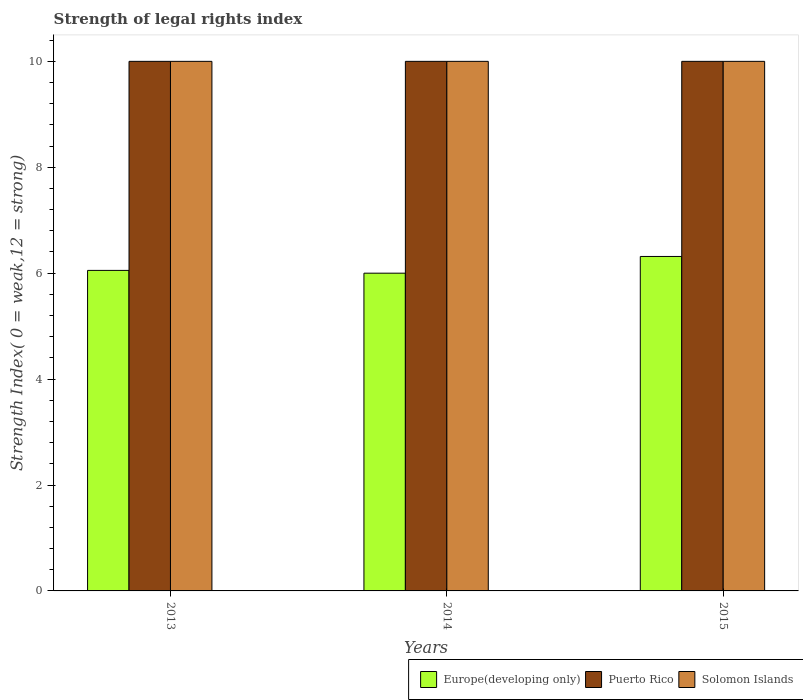How many different coloured bars are there?
Offer a very short reply. 3. Are the number of bars per tick equal to the number of legend labels?
Provide a short and direct response. Yes. Are the number of bars on each tick of the X-axis equal?
Ensure brevity in your answer.  Yes. How many bars are there on the 3rd tick from the right?
Your response must be concise. 3. What is the label of the 2nd group of bars from the left?
Your response must be concise. 2014. What is the strength index in Europe(developing only) in 2015?
Ensure brevity in your answer.  6.32. Across all years, what is the maximum strength index in Europe(developing only)?
Your response must be concise. 6.32. Across all years, what is the minimum strength index in Solomon Islands?
Offer a very short reply. 10. What is the total strength index in Europe(developing only) in the graph?
Provide a succinct answer. 18.37. What is the difference between the strength index in Puerto Rico in 2014 and that in 2015?
Offer a terse response. 0. What is the average strength index in Puerto Rico per year?
Keep it short and to the point. 10. In the year 2015, what is the difference between the strength index in Solomon Islands and strength index in Puerto Rico?
Provide a succinct answer. 0. What is the ratio of the strength index in Europe(developing only) in 2014 to that in 2015?
Your response must be concise. 0.95. Is the strength index in Puerto Rico in 2013 less than that in 2015?
Your answer should be very brief. No. Is the difference between the strength index in Solomon Islands in 2014 and 2015 greater than the difference between the strength index in Puerto Rico in 2014 and 2015?
Your response must be concise. No. What is the difference between the highest and the lowest strength index in Puerto Rico?
Provide a succinct answer. 0. What does the 2nd bar from the left in 2014 represents?
Your response must be concise. Puerto Rico. What does the 3rd bar from the right in 2015 represents?
Make the answer very short. Europe(developing only). How many years are there in the graph?
Keep it short and to the point. 3. What is the difference between two consecutive major ticks on the Y-axis?
Ensure brevity in your answer.  2. Does the graph contain any zero values?
Keep it short and to the point. No. Where does the legend appear in the graph?
Your answer should be very brief. Bottom right. What is the title of the graph?
Ensure brevity in your answer.  Strength of legal rights index. Does "American Samoa" appear as one of the legend labels in the graph?
Offer a terse response. No. What is the label or title of the Y-axis?
Your answer should be very brief. Strength Index( 0 = weak,12 = strong). What is the Strength Index( 0 = weak,12 = strong) in Europe(developing only) in 2013?
Your response must be concise. 6.05. What is the Strength Index( 0 = weak,12 = strong) in Puerto Rico in 2013?
Offer a very short reply. 10. What is the Strength Index( 0 = weak,12 = strong) in Europe(developing only) in 2015?
Ensure brevity in your answer.  6.32. What is the Strength Index( 0 = weak,12 = strong) of Puerto Rico in 2015?
Keep it short and to the point. 10. What is the Strength Index( 0 = weak,12 = strong) in Solomon Islands in 2015?
Your response must be concise. 10. Across all years, what is the maximum Strength Index( 0 = weak,12 = strong) of Europe(developing only)?
Give a very brief answer. 6.32. Across all years, what is the minimum Strength Index( 0 = weak,12 = strong) in Europe(developing only)?
Give a very brief answer. 6. Across all years, what is the minimum Strength Index( 0 = weak,12 = strong) of Puerto Rico?
Your response must be concise. 10. Across all years, what is the minimum Strength Index( 0 = weak,12 = strong) of Solomon Islands?
Your answer should be very brief. 10. What is the total Strength Index( 0 = weak,12 = strong) of Europe(developing only) in the graph?
Your answer should be compact. 18.37. What is the total Strength Index( 0 = weak,12 = strong) in Solomon Islands in the graph?
Keep it short and to the point. 30. What is the difference between the Strength Index( 0 = weak,12 = strong) of Europe(developing only) in 2013 and that in 2014?
Make the answer very short. 0.05. What is the difference between the Strength Index( 0 = weak,12 = strong) of Europe(developing only) in 2013 and that in 2015?
Your response must be concise. -0.26. What is the difference between the Strength Index( 0 = weak,12 = strong) of Puerto Rico in 2013 and that in 2015?
Provide a short and direct response. 0. What is the difference between the Strength Index( 0 = weak,12 = strong) in Europe(developing only) in 2014 and that in 2015?
Keep it short and to the point. -0.32. What is the difference between the Strength Index( 0 = weak,12 = strong) of Solomon Islands in 2014 and that in 2015?
Your answer should be compact. 0. What is the difference between the Strength Index( 0 = weak,12 = strong) in Europe(developing only) in 2013 and the Strength Index( 0 = weak,12 = strong) in Puerto Rico in 2014?
Your response must be concise. -3.95. What is the difference between the Strength Index( 0 = weak,12 = strong) in Europe(developing only) in 2013 and the Strength Index( 0 = weak,12 = strong) in Solomon Islands in 2014?
Provide a short and direct response. -3.95. What is the difference between the Strength Index( 0 = weak,12 = strong) in Europe(developing only) in 2013 and the Strength Index( 0 = weak,12 = strong) in Puerto Rico in 2015?
Offer a very short reply. -3.95. What is the difference between the Strength Index( 0 = weak,12 = strong) of Europe(developing only) in 2013 and the Strength Index( 0 = weak,12 = strong) of Solomon Islands in 2015?
Ensure brevity in your answer.  -3.95. What is the difference between the Strength Index( 0 = weak,12 = strong) of Puerto Rico in 2013 and the Strength Index( 0 = weak,12 = strong) of Solomon Islands in 2015?
Provide a succinct answer. 0. What is the difference between the Strength Index( 0 = weak,12 = strong) in Europe(developing only) in 2014 and the Strength Index( 0 = weak,12 = strong) in Puerto Rico in 2015?
Ensure brevity in your answer.  -4. What is the difference between the Strength Index( 0 = weak,12 = strong) of Europe(developing only) in 2014 and the Strength Index( 0 = weak,12 = strong) of Solomon Islands in 2015?
Keep it short and to the point. -4. What is the average Strength Index( 0 = weak,12 = strong) of Europe(developing only) per year?
Provide a succinct answer. 6.12. What is the average Strength Index( 0 = weak,12 = strong) in Puerto Rico per year?
Ensure brevity in your answer.  10. What is the average Strength Index( 0 = weak,12 = strong) of Solomon Islands per year?
Make the answer very short. 10. In the year 2013, what is the difference between the Strength Index( 0 = weak,12 = strong) in Europe(developing only) and Strength Index( 0 = weak,12 = strong) in Puerto Rico?
Your answer should be very brief. -3.95. In the year 2013, what is the difference between the Strength Index( 0 = weak,12 = strong) in Europe(developing only) and Strength Index( 0 = weak,12 = strong) in Solomon Islands?
Ensure brevity in your answer.  -3.95. In the year 2013, what is the difference between the Strength Index( 0 = weak,12 = strong) in Puerto Rico and Strength Index( 0 = weak,12 = strong) in Solomon Islands?
Make the answer very short. 0. In the year 2015, what is the difference between the Strength Index( 0 = weak,12 = strong) of Europe(developing only) and Strength Index( 0 = weak,12 = strong) of Puerto Rico?
Provide a short and direct response. -3.68. In the year 2015, what is the difference between the Strength Index( 0 = weak,12 = strong) of Europe(developing only) and Strength Index( 0 = weak,12 = strong) of Solomon Islands?
Your response must be concise. -3.68. What is the ratio of the Strength Index( 0 = weak,12 = strong) in Europe(developing only) in 2013 to that in 2014?
Offer a terse response. 1.01. What is the ratio of the Strength Index( 0 = weak,12 = strong) of Solomon Islands in 2013 to that in 2014?
Provide a short and direct response. 1. What is the ratio of the Strength Index( 0 = weak,12 = strong) of Puerto Rico in 2013 to that in 2015?
Your response must be concise. 1. What is the ratio of the Strength Index( 0 = weak,12 = strong) of Solomon Islands in 2013 to that in 2015?
Make the answer very short. 1. What is the ratio of the Strength Index( 0 = weak,12 = strong) in Puerto Rico in 2014 to that in 2015?
Offer a very short reply. 1. What is the ratio of the Strength Index( 0 = weak,12 = strong) in Solomon Islands in 2014 to that in 2015?
Keep it short and to the point. 1. What is the difference between the highest and the second highest Strength Index( 0 = weak,12 = strong) in Europe(developing only)?
Make the answer very short. 0.26. What is the difference between the highest and the second highest Strength Index( 0 = weak,12 = strong) of Puerto Rico?
Your response must be concise. 0. What is the difference between the highest and the lowest Strength Index( 0 = weak,12 = strong) in Europe(developing only)?
Ensure brevity in your answer.  0.32. What is the difference between the highest and the lowest Strength Index( 0 = weak,12 = strong) of Solomon Islands?
Keep it short and to the point. 0. 